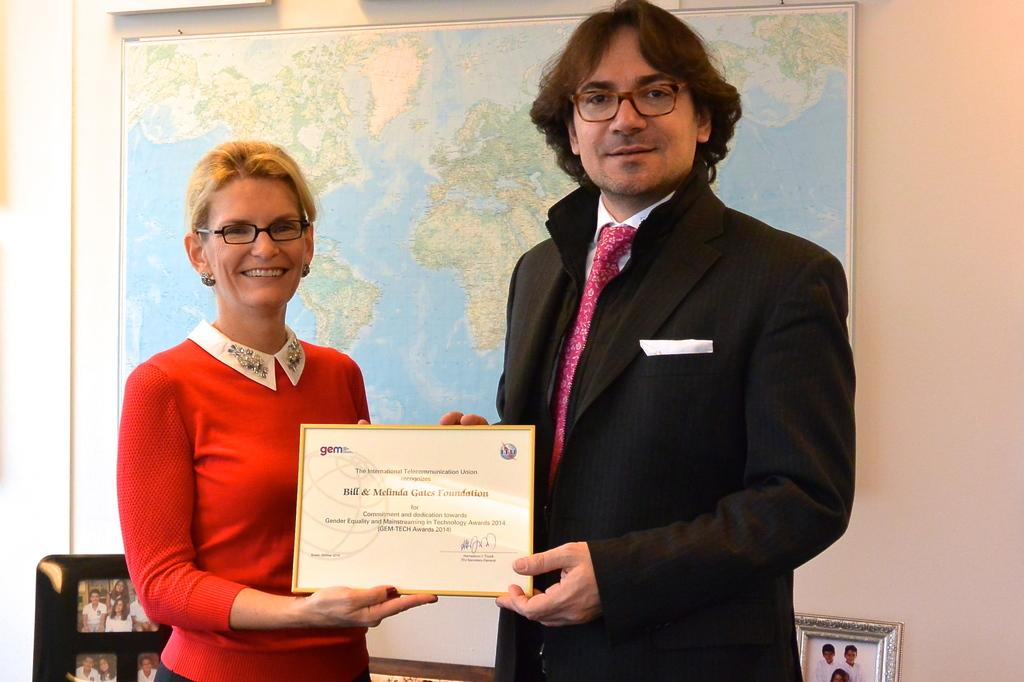How many people are in the image? There are two persons in the image. What are the persons doing in the image? The persons are standing and smiling. What are they holding in the image? They are holding a certificate. What can be seen on the wall in the background? There is a map attached to the wall in the background. What else can be seen in the background? There are photo frames in the background. What type of hot dog is being served in the image? There is no hot dog present in the image. How does the dog in the image feel about the certificate? There is no dog present in the image. 